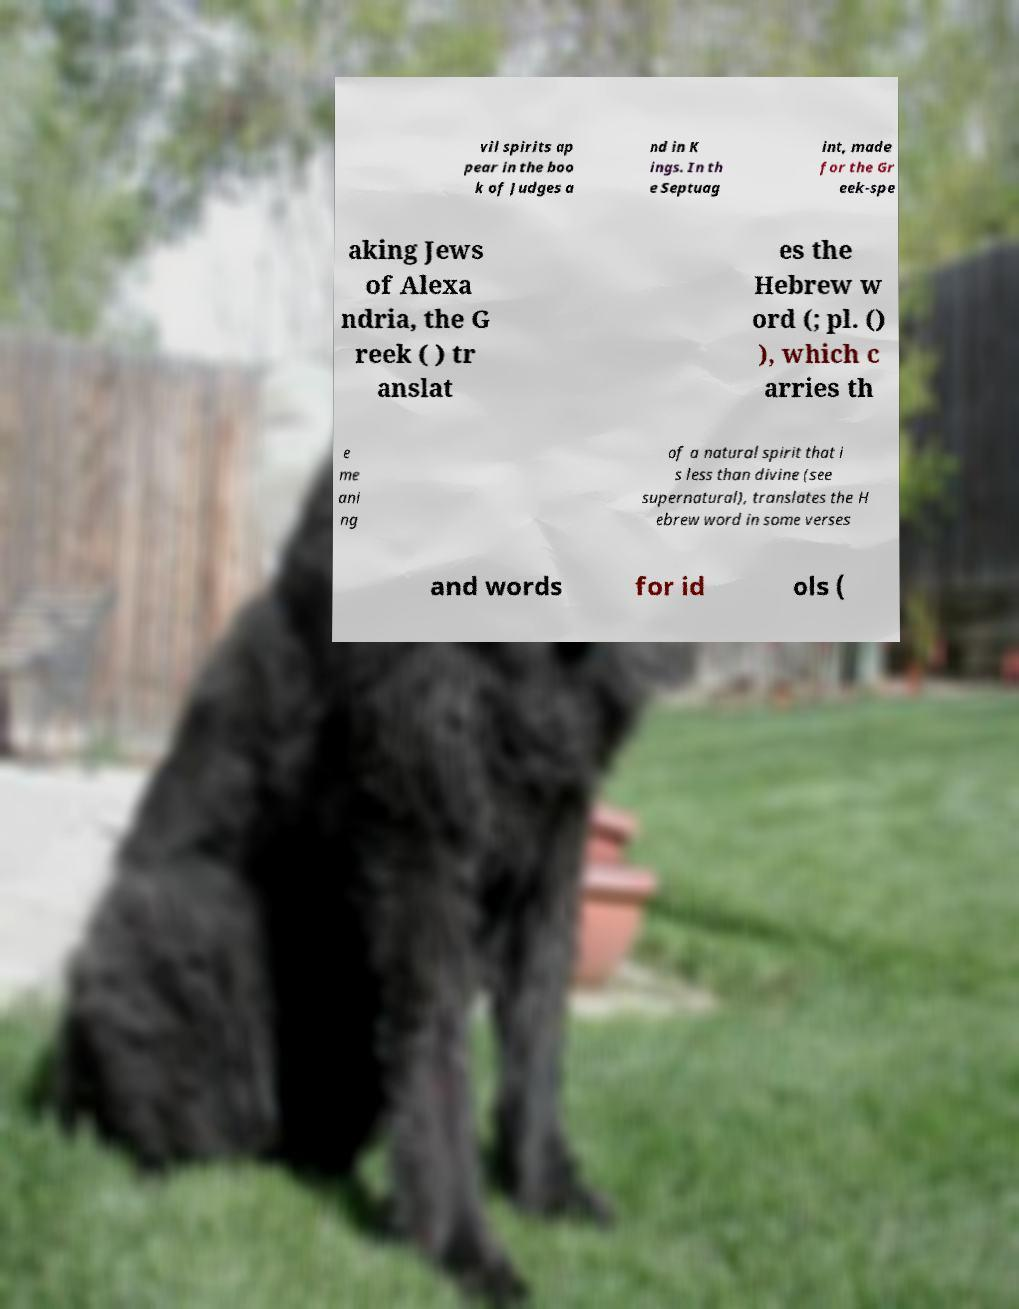Please identify and transcribe the text found in this image. vil spirits ap pear in the boo k of Judges a nd in K ings. In th e Septuag int, made for the Gr eek-spe aking Jews of Alexa ndria, the G reek ( ) tr anslat es the Hebrew w ord (; pl. () ), which c arries th e me ani ng of a natural spirit that i s less than divine (see supernatural), translates the H ebrew word in some verses and words for id ols ( 